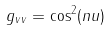Convert formula to latex. <formula><loc_0><loc_0><loc_500><loc_500>g _ { v v } = \cos ^ { 2 } ( n u )</formula> 